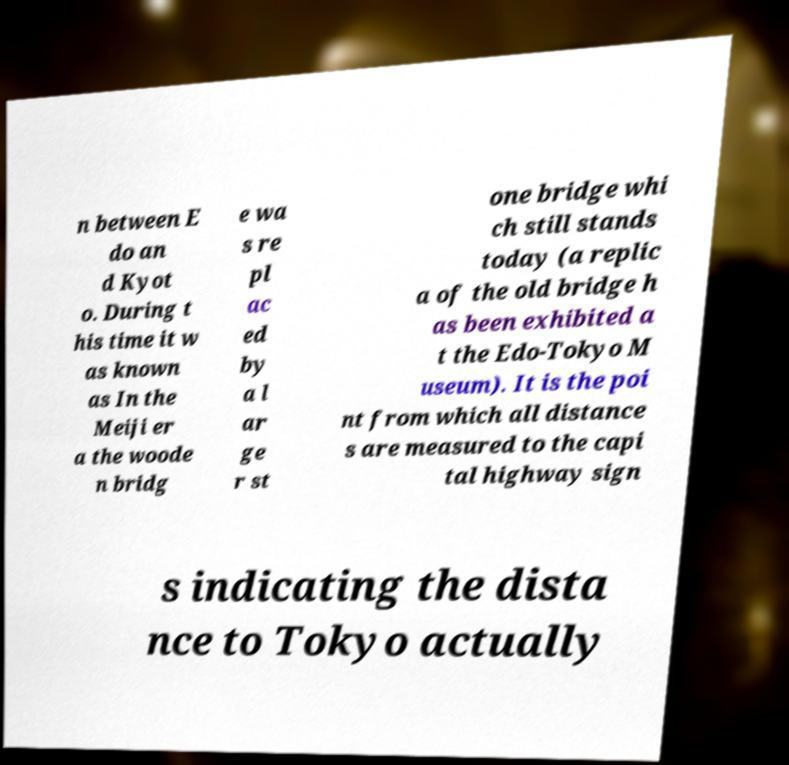What messages or text are displayed in this image? I need them in a readable, typed format. n between E do an d Kyot o. During t his time it w as known as In the Meiji er a the woode n bridg e wa s re pl ac ed by a l ar ge r st one bridge whi ch still stands today (a replic a of the old bridge h as been exhibited a t the Edo-Tokyo M useum). It is the poi nt from which all distance s are measured to the capi tal highway sign s indicating the dista nce to Tokyo actually 